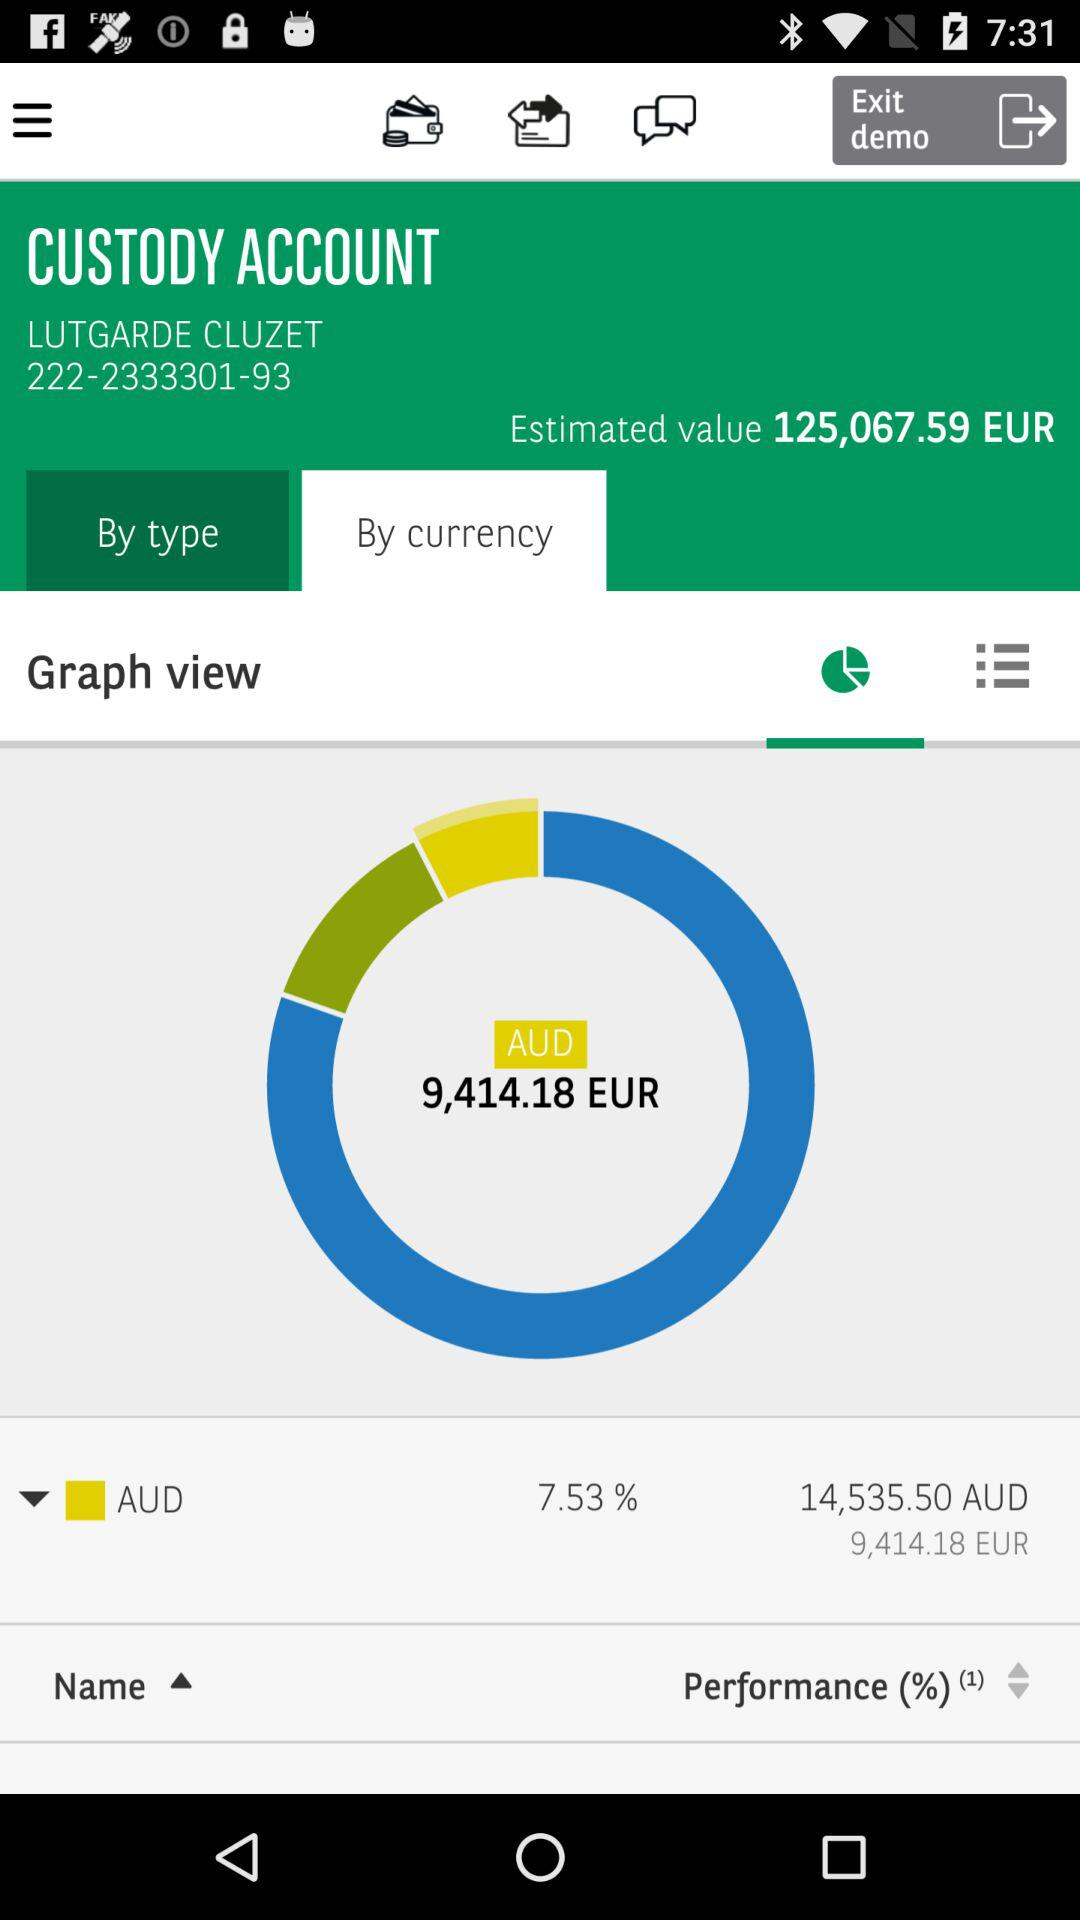What is the percentage of my account that is in AUD?
Answer the question using a single word or phrase. 7.53% 